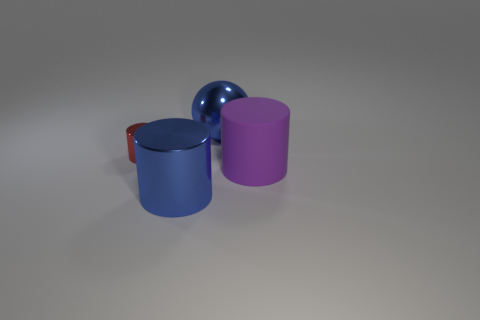There is a big cylinder that is the same color as the sphere; what is its material?
Keep it short and to the point. Metal. What size is the cylinder that is the same color as the metal ball?
Your answer should be compact. Large. Does the rubber object have the same color as the shiny sphere?
Make the answer very short. No. What is the shape of the small object?
Provide a short and direct response. Cylinder. There is a big metal ball right of the metal thing that is in front of the tiny red cylinder; is there a red metal cylinder to the left of it?
Your answer should be compact. Yes. There is a thing behind the cylinder to the left of the blue shiny object in front of the big metallic sphere; what color is it?
Keep it short and to the point. Blue. There is another blue thing that is the same shape as the tiny shiny object; what is it made of?
Offer a very short reply. Metal. There is a blue object that is behind the shiny cylinder that is in front of the purple cylinder; how big is it?
Offer a very short reply. Large. There is a thing that is behind the small red metallic object; what material is it?
Keep it short and to the point. Metal. The red cylinder that is made of the same material as the big ball is what size?
Keep it short and to the point. Small. 